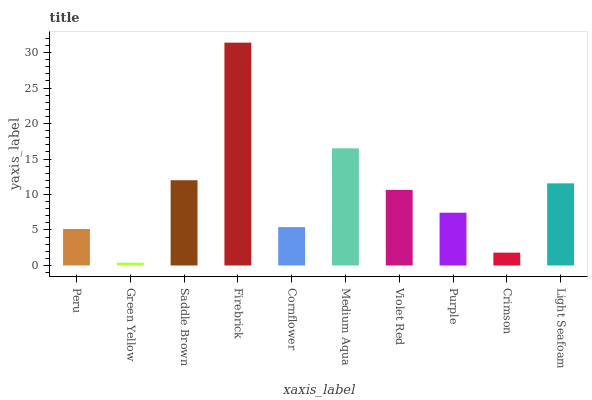Is Green Yellow the minimum?
Answer yes or no. Yes. Is Firebrick the maximum?
Answer yes or no. Yes. Is Saddle Brown the minimum?
Answer yes or no. No. Is Saddle Brown the maximum?
Answer yes or no. No. Is Saddle Brown greater than Green Yellow?
Answer yes or no. Yes. Is Green Yellow less than Saddle Brown?
Answer yes or no. Yes. Is Green Yellow greater than Saddle Brown?
Answer yes or no. No. Is Saddle Brown less than Green Yellow?
Answer yes or no. No. Is Violet Red the high median?
Answer yes or no. Yes. Is Purple the low median?
Answer yes or no. Yes. Is Peru the high median?
Answer yes or no. No. Is Violet Red the low median?
Answer yes or no. No. 